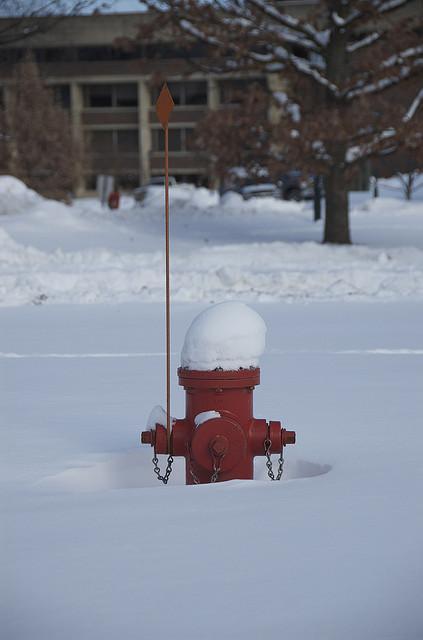How many chains on the hydrant?
Give a very brief answer. 2. 